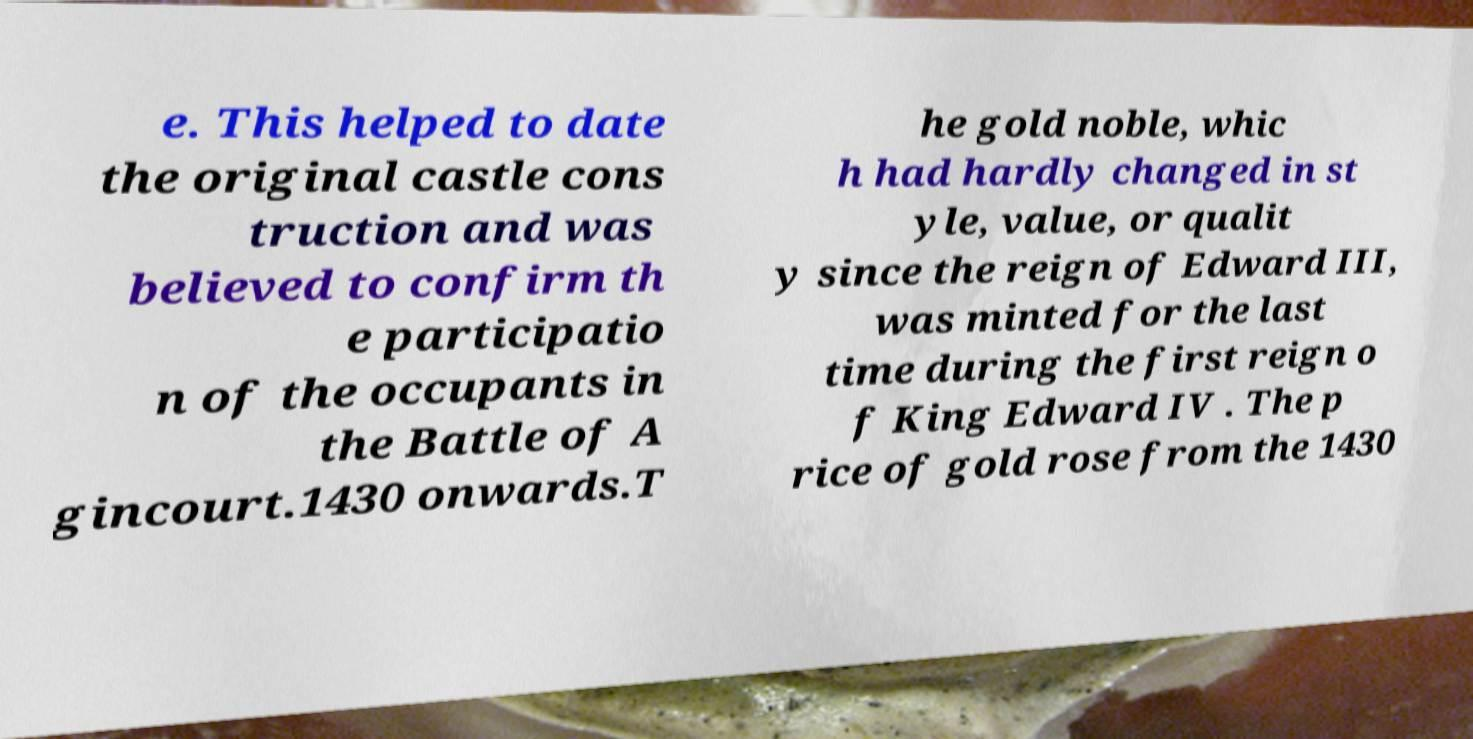For documentation purposes, I need the text within this image transcribed. Could you provide that? e. This helped to date the original castle cons truction and was believed to confirm th e participatio n of the occupants in the Battle of A gincourt.1430 onwards.T he gold noble, whic h had hardly changed in st yle, value, or qualit y since the reign of Edward III, was minted for the last time during the first reign o f King Edward IV . The p rice of gold rose from the 1430 